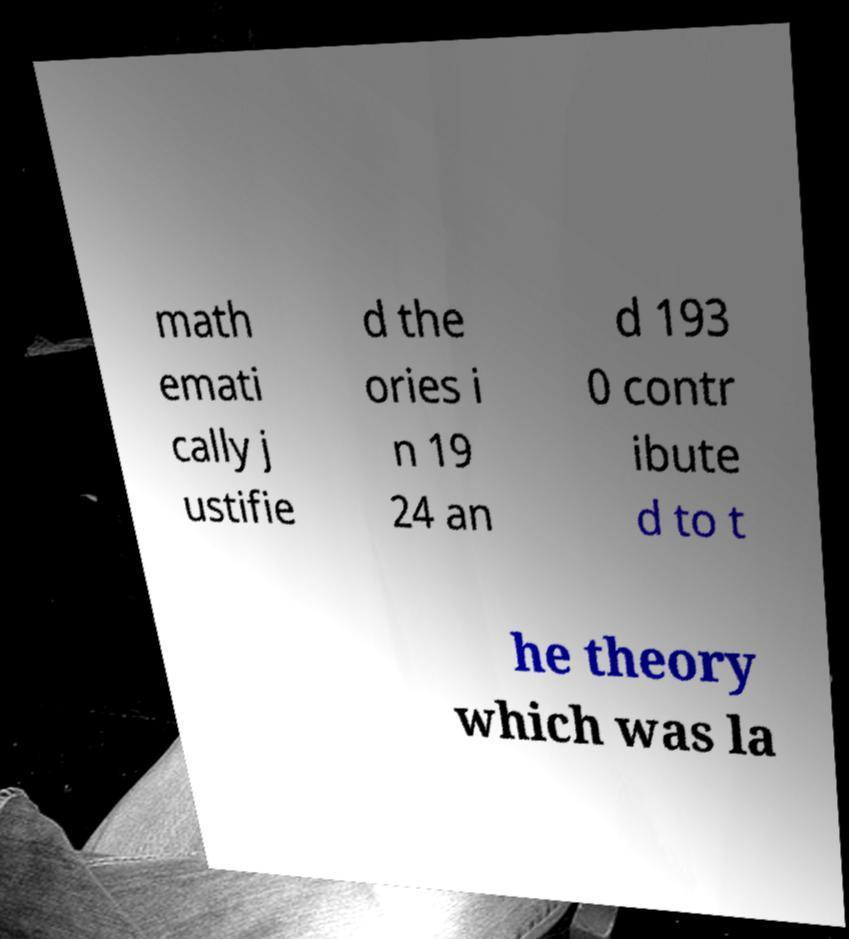Please read and relay the text visible in this image. What does it say? math emati cally j ustifie d the ories i n 19 24 an d 193 0 contr ibute d to t he theory which was la 